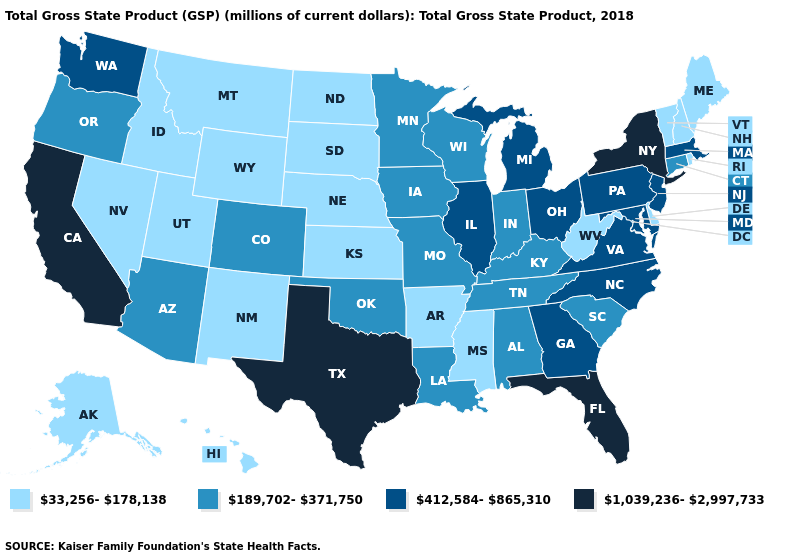What is the value of Utah?
Give a very brief answer. 33,256-178,138. What is the value of Nevada?
Short answer required. 33,256-178,138. Does the map have missing data?
Give a very brief answer. No. Does North Dakota have the lowest value in the MidWest?
Concise answer only. Yes. What is the value of North Dakota?
Be succinct. 33,256-178,138. What is the value of Texas?
Keep it brief. 1,039,236-2,997,733. Does Oregon have a lower value than Florida?
Short answer required. Yes. What is the lowest value in the USA?
Quick response, please. 33,256-178,138. Among the states that border Colorado , does Wyoming have the lowest value?
Give a very brief answer. Yes. Name the states that have a value in the range 33,256-178,138?
Short answer required. Alaska, Arkansas, Delaware, Hawaii, Idaho, Kansas, Maine, Mississippi, Montana, Nebraska, Nevada, New Hampshire, New Mexico, North Dakota, Rhode Island, South Dakota, Utah, Vermont, West Virginia, Wyoming. Which states have the lowest value in the USA?
Give a very brief answer. Alaska, Arkansas, Delaware, Hawaii, Idaho, Kansas, Maine, Mississippi, Montana, Nebraska, Nevada, New Hampshire, New Mexico, North Dakota, Rhode Island, South Dakota, Utah, Vermont, West Virginia, Wyoming. What is the highest value in states that border Ohio?
Answer briefly. 412,584-865,310. Does New York have the highest value in the USA?
Answer briefly. Yes. Among the states that border West Virginia , which have the highest value?
Quick response, please. Maryland, Ohio, Pennsylvania, Virginia. Does Texas have the highest value in the USA?
Answer briefly. Yes. 